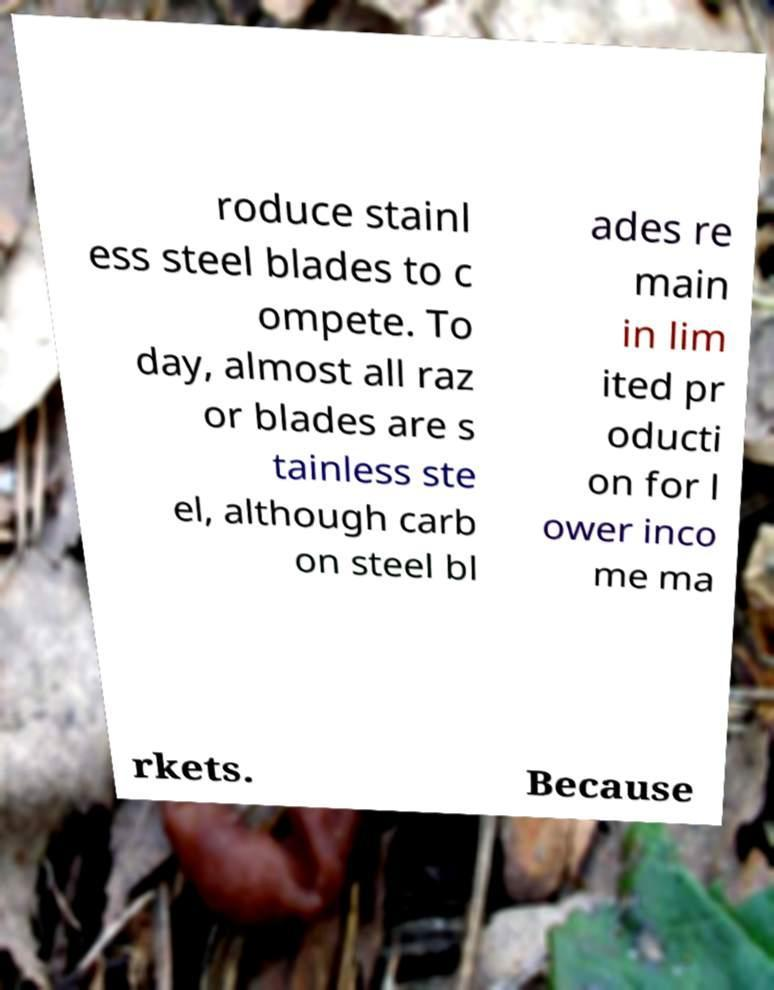Can you read and provide the text displayed in the image?This photo seems to have some interesting text. Can you extract and type it out for me? roduce stainl ess steel blades to c ompete. To day, almost all raz or blades are s tainless ste el, although carb on steel bl ades re main in lim ited pr oducti on for l ower inco me ma rkets. Because 